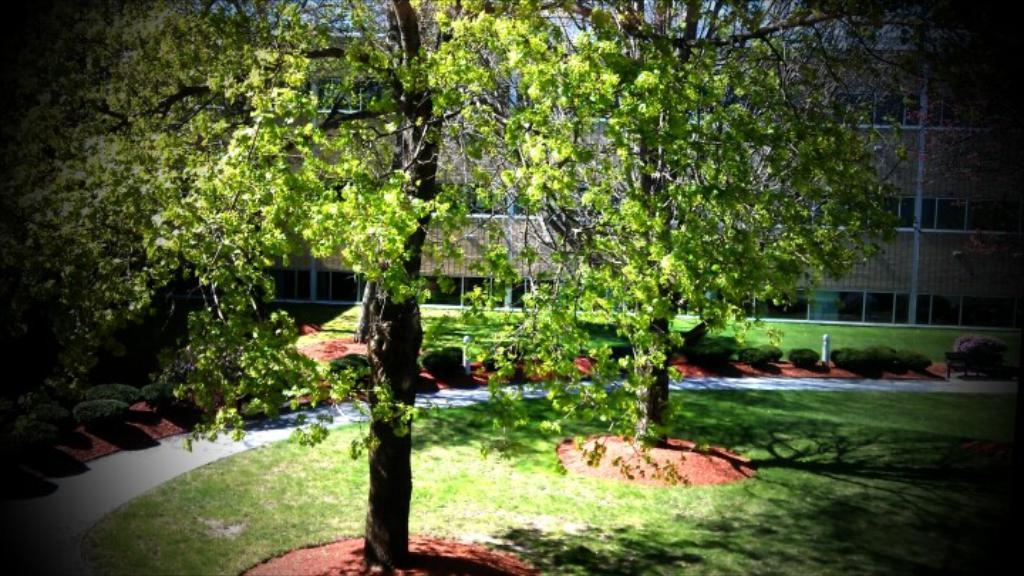How many trees are visible in the image? There are two trees in the image. What is the ground made of in the image? The trees are placed on a greenery ground. What can be seen in the background of the image? There are additional trees and a building in the background of the image. What type of knife can be seen cutting through the circle in the image? There is no knife or circle present in the image; it features two trees and a background with additional trees and a building. 